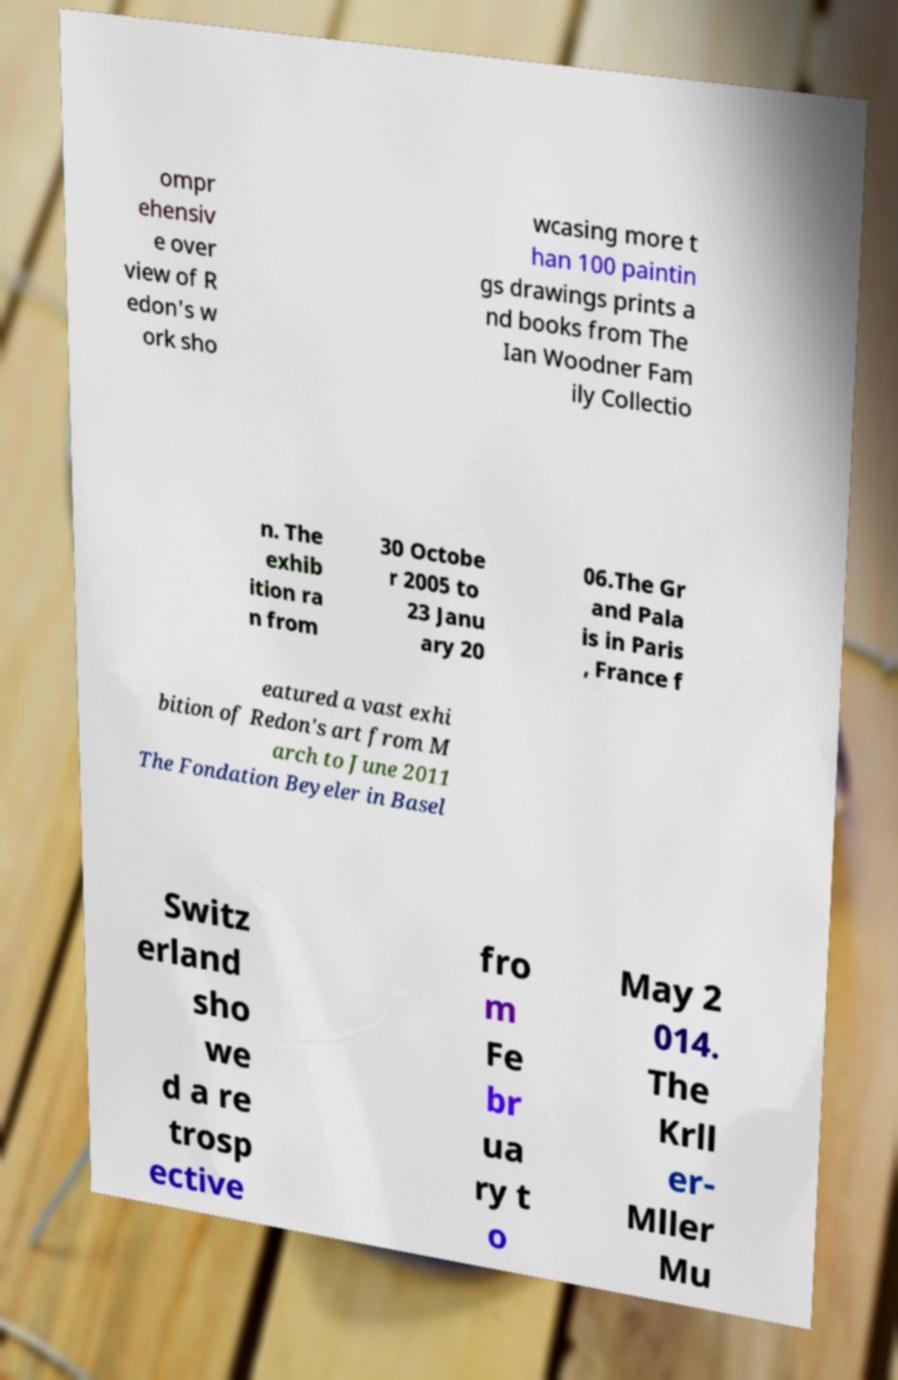Could you assist in decoding the text presented in this image and type it out clearly? ompr ehensiv e over view of R edon's w ork sho wcasing more t han 100 paintin gs drawings prints a nd books from The Ian Woodner Fam ily Collectio n. The exhib ition ra n from 30 Octobe r 2005 to 23 Janu ary 20 06.The Gr and Pala is in Paris , France f eatured a vast exhi bition of Redon's art from M arch to June 2011 The Fondation Beyeler in Basel Switz erland sho we d a re trosp ective fro m Fe br ua ry t o May 2 014. The Krll er- Mller Mu 